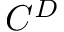Convert formula to latex. <formula><loc_0><loc_0><loc_500><loc_500>C ^ { D }</formula> 